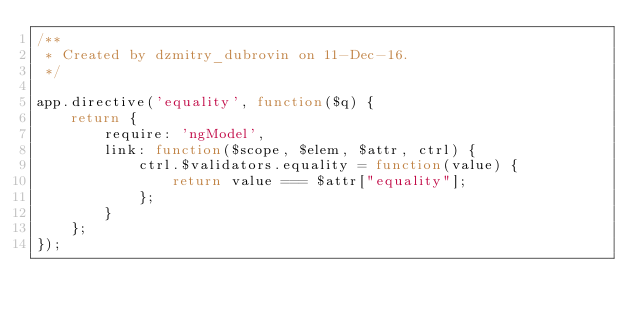<code> <loc_0><loc_0><loc_500><loc_500><_JavaScript_>/**
 * Created by dzmitry_dubrovin on 11-Dec-16.
 */

app.directive('equality', function($q) {
    return {
        require: 'ngModel',
        link: function($scope, $elem, $attr, ctrl) {
            ctrl.$validators.equality = function(value) {
                return value === $attr["equality"];
            };
        }
    };
});</code> 